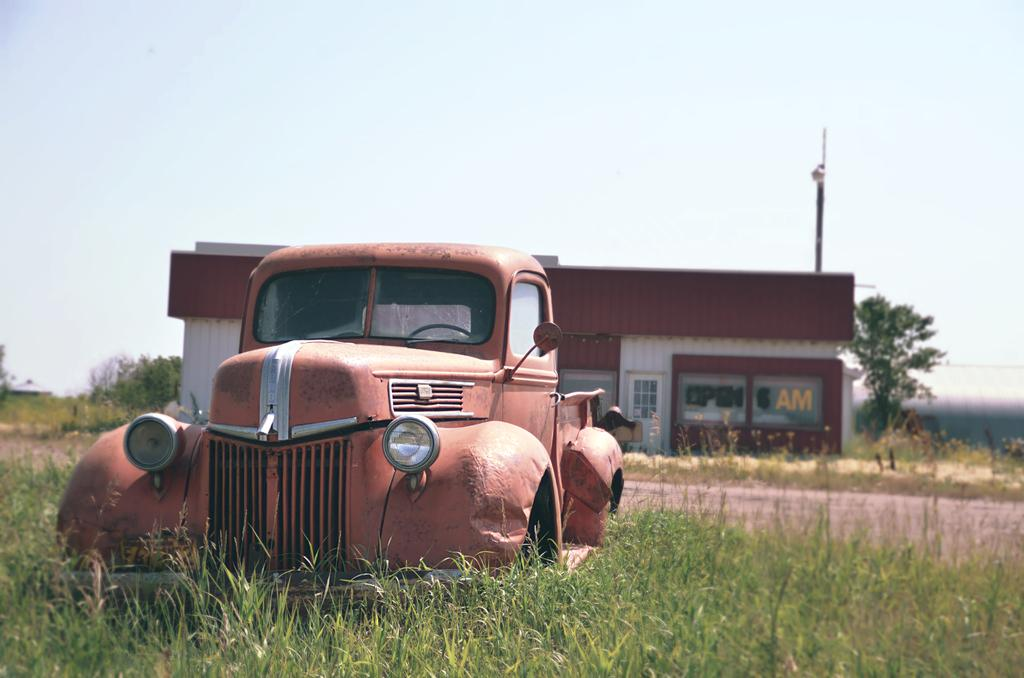What is the main subject of the image? The main subject of the image is a car. Where is the car located in the image? The car is visible on grass in the image. What can be seen behind the car? The backside of the car shows a road, building, and a tree. What is visible at the top of the image? The sky is visible at the top of the image. When was the image taken? The image was taken during the day. How many hills can be seen in the image? There are no hills visible in the image. What type of temper does the car have in the image? Cars do not have a temper; they are inanimate objects. 